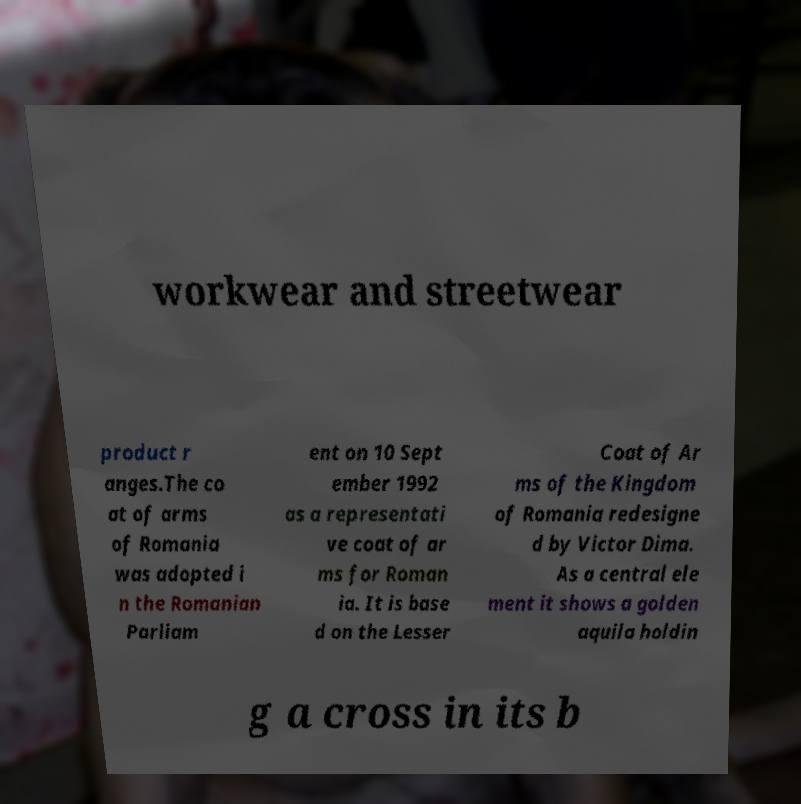Please read and relay the text visible in this image. What does it say? workwear and streetwear product r anges.The co at of arms of Romania was adopted i n the Romanian Parliam ent on 10 Sept ember 1992 as a representati ve coat of ar ms for Roman ia. It is base d on the Lesser Coat of Ar ms of the Kingdom of Romania redesigne d by Victor Dima. As a central ele ment it shows a golden aquila holdin g a cross in its b 